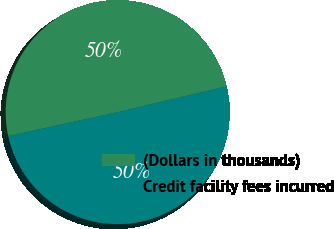Convert chart. <chart><loc_0><loc_0><loc_500><loc_500><pie_chart><fcel>(Dollars in thousands)<fcel>Credit facility fees incurred<nl><fcel>49.7%<fcel>50.3%<nl></chart> 